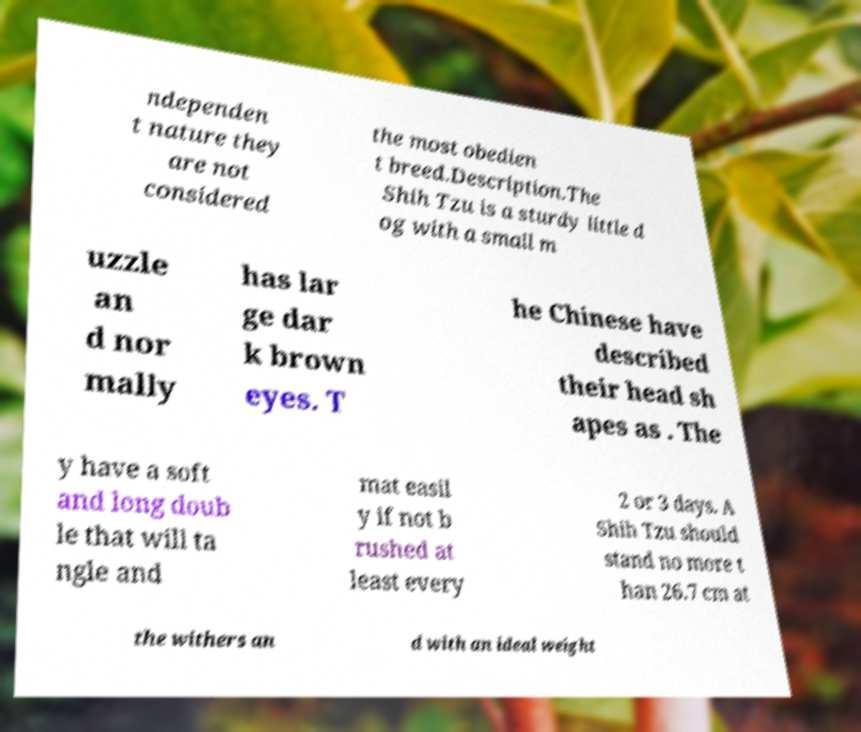For documentation purposes, I need the text within this image transcribed. Could you provide that? ndependen t nature they are not considered the most obedien t breed.Description.The Shih Tzu is a sturdy little d og with a small m uzzle an d nor mally has lar ge dar k brown eyes. T he Chinese have described their head sh apes as . The y have a soft and long doub le that will ta ngle and mat easil y if not b rushed at least every 2 or 3 days. A Shih Tzu should stand no more t han 26.7 cm at the withers an d with an ideal weight 